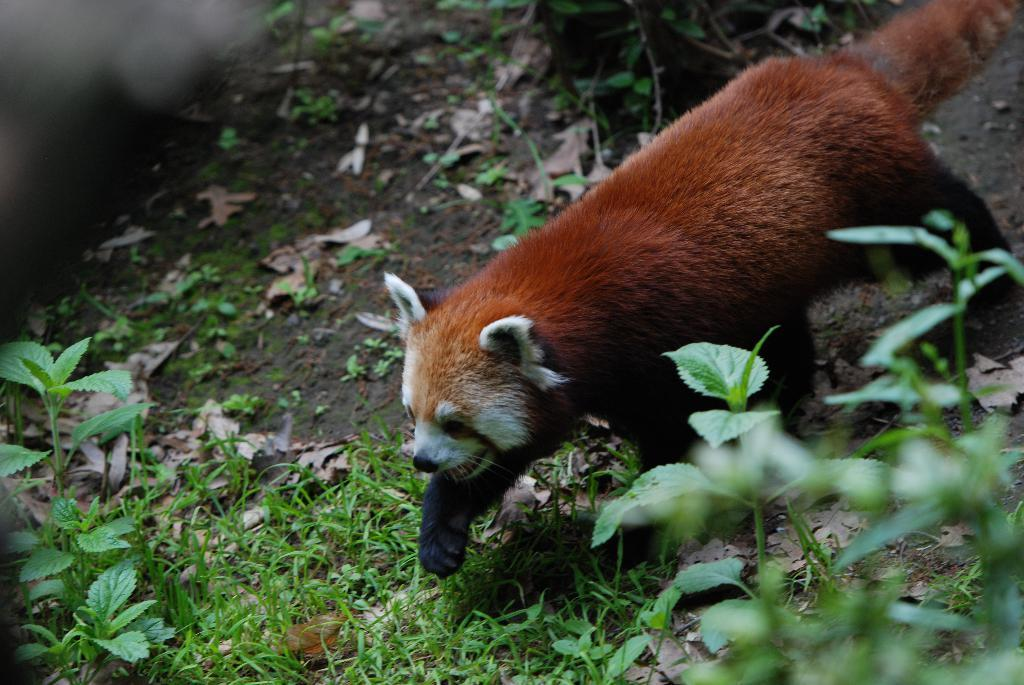What type of animal is in the image? There is a red panda in the image. What is the red panda doing in the image? The red panda is walking. What can be seen at the bottom of the image? There are plants at the bottom of the image. What is visible in the background of the image? Leaves are visible in the background of the image. What type of wrist support is the red panda using while walking in the image? There is no wrist support present in the image, as the red panda is walking without any visible support. 